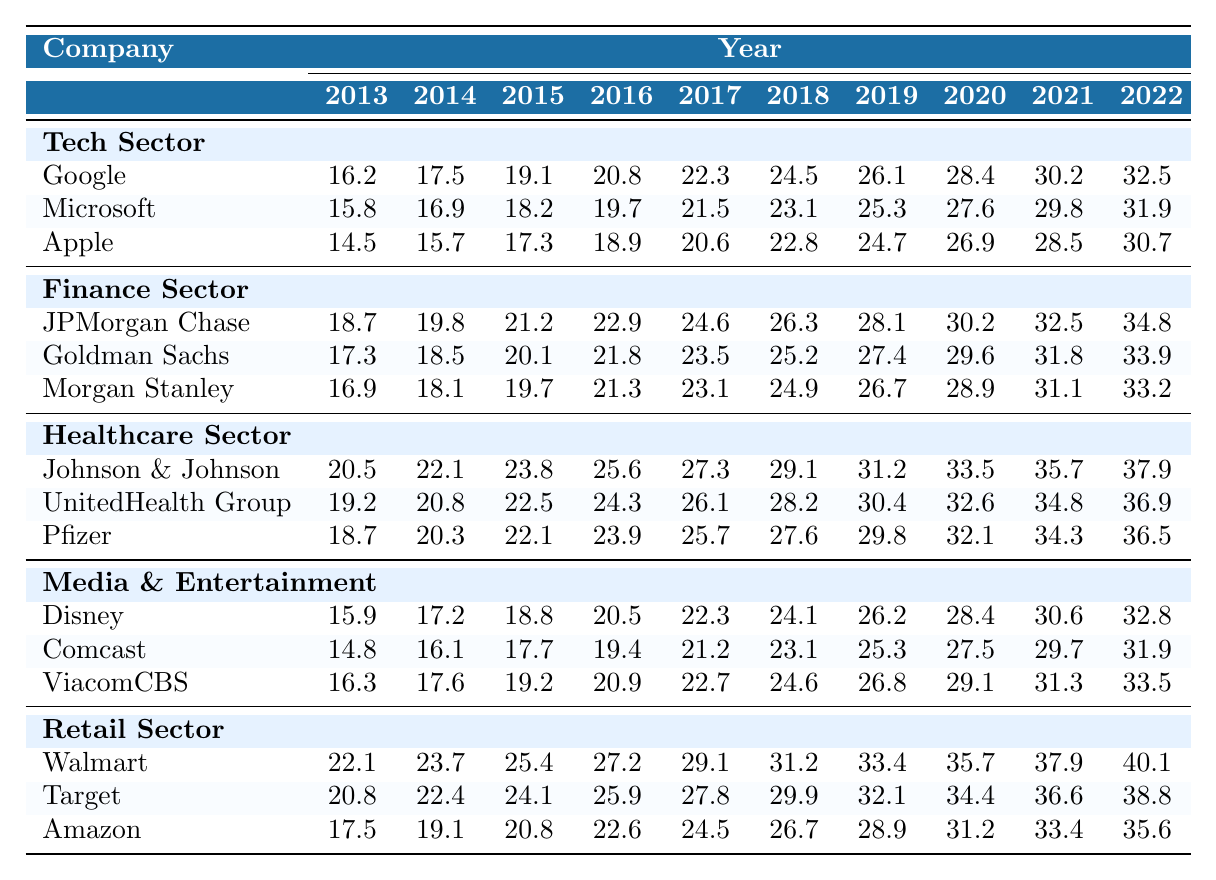What percentage of leadership roles in Google were held by minorities in 2022? In 2022, the percentage of leadership roles in Google held by minorities was 32.5%. This is directly taken from the table for the year 2022 under the Tech Sector section.
Answer: 32.5% Which company had the highest representation of minorities in leadership roles in the Finance Sector in 2021? In 2021, JPMorgan Chase had the highest representation of minorities in leadership roles in the Finance Sector at 32.5%. This is the highest value listed for the years under the Finance Sector for that year.
Answer: JPMorgan Chase What is the difference in minority representation between the Healthcare and Tech Sectors in 2019? In 2019, minority representation in the Healthcare Sector (Johnson & Johnson: 31.2%) and Tech Sector (Google: 26.1%) can be compared. The difference is calculated as 31.2% - 26.1% = 5.1%.
Answer: 5.1% Did all companies in the Media & Entertainment Sector show an increase in minority representation from 2013 to 2022? Upon reviewing the values from 2013 to 2022, all three companies (Disney, Comcast, ViacomCBS) show an increase in minority representation year over year. Therefore, the statement is true.
Answer: Yes What is the average percentage of minority representation across all companies in the Retail Sector in 2021? The percentages for 2021 are: Walmart (37.9%), Target (36.6%), and Amazon (33.4%). The average is calculated as (37.9 + 36.6 + 33.4) / 3 = 35.63%.
Answer: 35.63% Which sector had the lowest representation of minorities in 2014? By comparing the values in 2014, the Media & Entertainment Sector (Comcast at 16.1%) had the lowest representation among all sectors for that year, making it the sector with the lowest value.
Answer: Media & Entertainment What percentage growth in leadership representation did Apple achieve from 2013 to 2022? For Apple, the representation grew from 14.5% in 2013 to 30.7% in 2022. The percentage growth is calculated as (30.7 - 14.5) / 14.5 * 100 = 111.72%.
Answer: 111.72% What is the trend in minority representation in leadership roles across the Tech Sector from 2013 to 2022? Observing the values from 2013 (16.2%) to 2022 (32.5%), there is a consistent upward trend, indicating that the representation of minorities in leadership roles has significantly increased over the decade.
Answer: Upward trend How does Morgan Stanley's representation of minorities in 2018 compare to its representation in 2022? In 2018, Morgan Stanley's representation was 24.9%, whereas it improved to 33.2% in 2022. Calculating the change gives 33.2% - 24.9% = 8.3%. This shows a positive difference.
Answer: Increased by 8.3% 